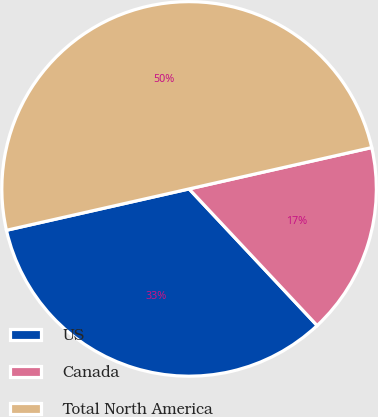Convert chart to OTSL. <chart><loc_0><loc_0><loc_500><loc_500><pie_chart><fcel>US<fcel>Canada<fcel>Total North America<nl><fcel>33.44%<fcel>16.56%<fcel>50.0%<nl></chart> 